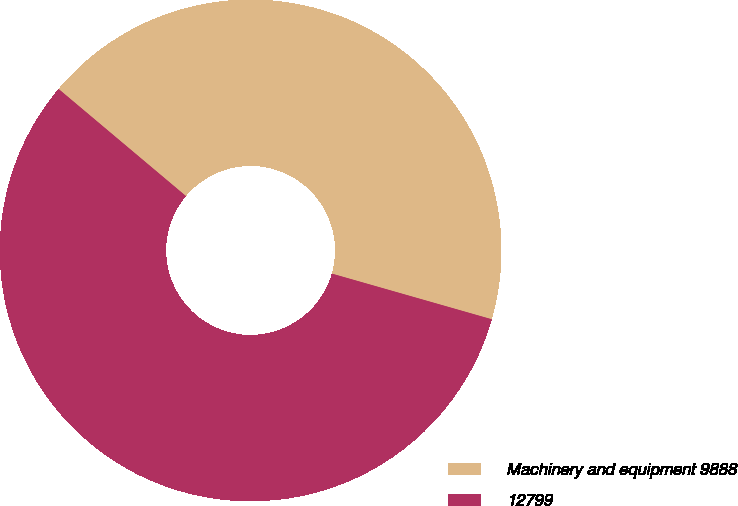<chart> <loc_0><loc_0><loc_500><loc_500><pie_chart><fcel>Machinery and equipment 9888<fcel>12799<nl><fcel>43.3%<fcel>56.7%<nl></chart> 